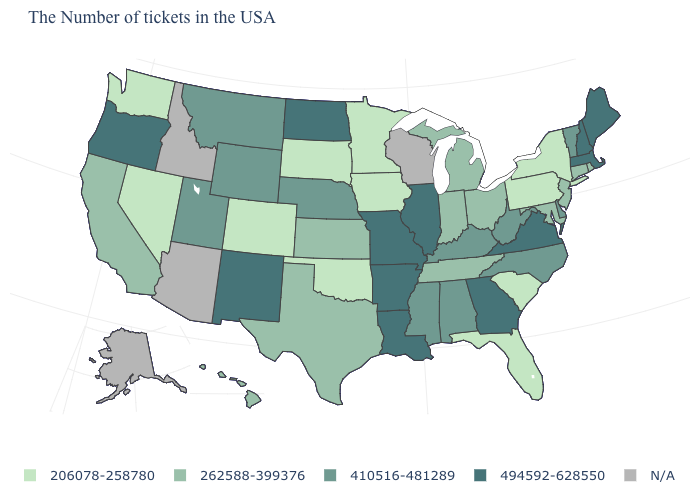Which states have the lowest value in the Northeast?
Quick response, please. New York, Pennsylvania. What is the value of Nebraska?
Keep it brief. 410516-481289. What is the value of Washington?
Short answer required. 206078-258780. What is the value of Oregon?
Keep it brief. 494592-628550. Name the states that have a value in the range 262588-399376?
Be succinct. Rhode Island, Connecticut, New Jersey, Maryland, Ohio, Michigan, Indiana, Tennessee, Kansas, Texas, California, Hawaii. Does the map have missing data?
Give a very brief answer. Yes. What is the value of Washington?
Write a very short answer. 206078-258780. What is the highest value in the West ?
Short answer required. 494592-628550. What is the lowest value in the USA?
Short answer required. 206078-258780. What is the value of New Jersey?
Answer briefly. 262588-399376. What is the lowest value in the South?
Keep it brief. 206078-258780. Does North Carolina have the highest value in the USA?
Write a very short answer. No. What is the value of North Dakota?
Quick response, please. 494592-628550. 